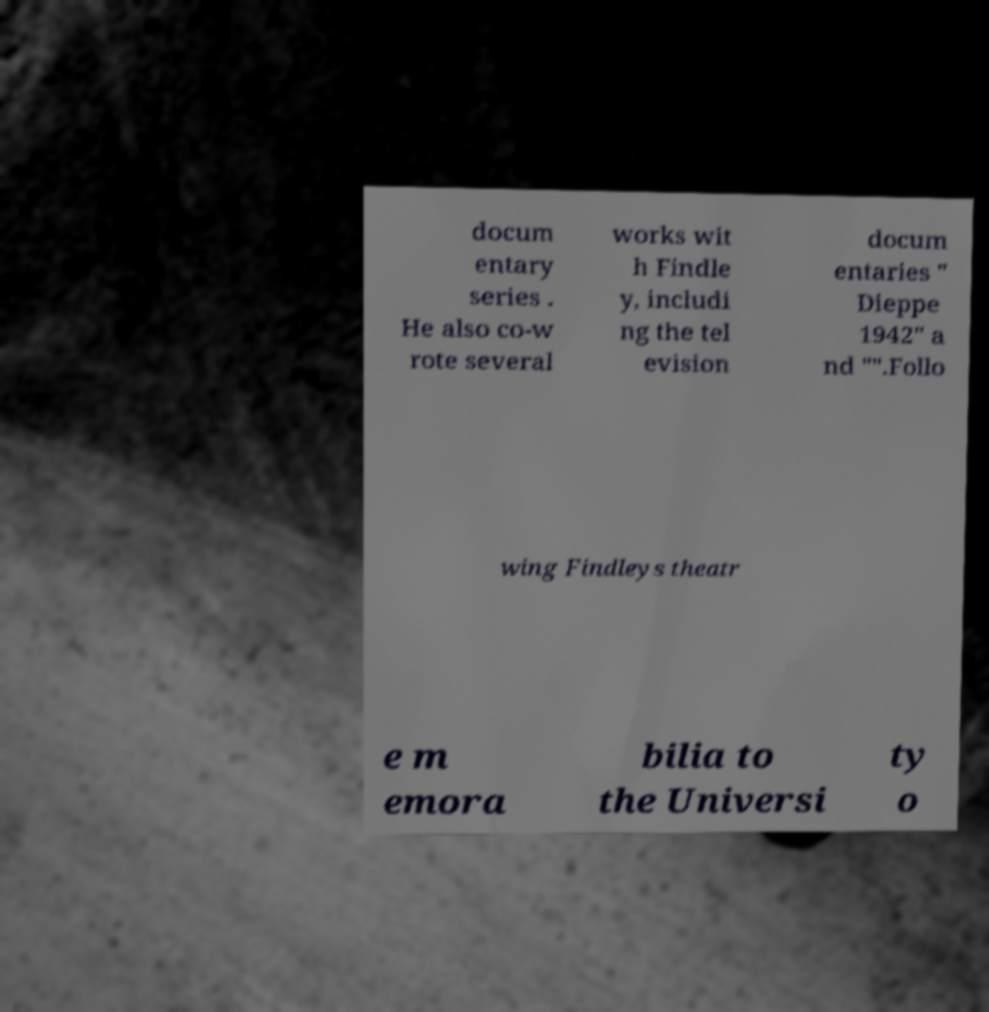Could you assist in decoding the text presented in this image and type it out clearly? docum entary series . He also co-w rote several works wit h Findle y, includi ng the tel evision docum entaries " Dieppe 1942" a nd "".Follo wing Findleys theatr e m emora bilia to the Universi ty o 